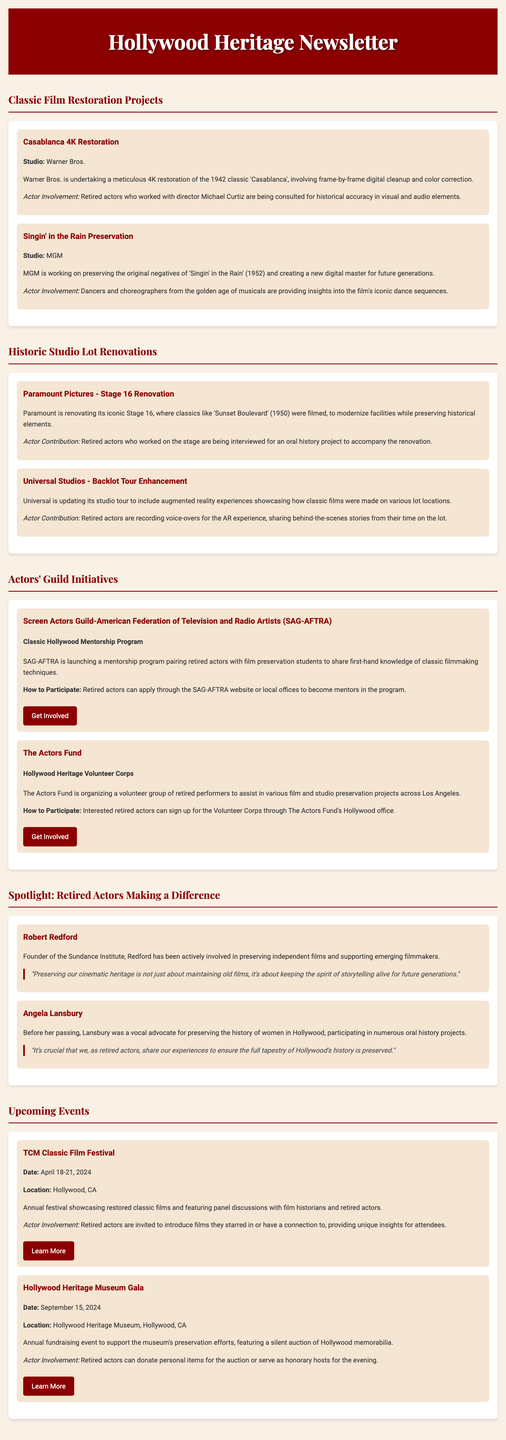what is the project name of Warner Bros.' restoration? The project name for Warner Bros.' restoration is mentioned in the section about Classic Film Restoration Projects.
Answer: Casablanca 4K Restoration who is consulting for the Casablanca restoration project? The document indicates that retired actors who worked with the director Michael Curtiz are being consulted for historical accuracy.
Answer: Retired actors what studio is involved in the Singin' in the Rain preservation? The studio working on preserving Singin' in the Rain is stated in the project details under Classic Film Restoration Projects.
Answer: MGM when is the TCM Classic Film Festival taking place? The date for the TCM Classic Film Festival is provided in the Upcoming Events section of the document.
Answer: April 18-21, 2024 what is the initiative launched by SAG-AFTRA? The initiative launched by SAG-AFTRA is detailed in the Actors' Guild Initiatives section.
Answer: Classic Hollywood Mentorship Program how can retired actors participate in the Hollywood Heritage Volunteer Corps? The document specifies how interested retired actors can engage with the Volunteer Corps initiative.
Answer: Sign up through The Actors Fund's Hollywood office which retired actor founded the Sundance Institute? The Spotlight section provides information about retired actors making a difference, including their contributions.
Answer: Robert Redford what type of event is the Hollywood Heritage Museum Gala? The type of event for the Hollywood Heritage Museum Gala is described in the Upcoming Events section.
Answer: Fundraising event 